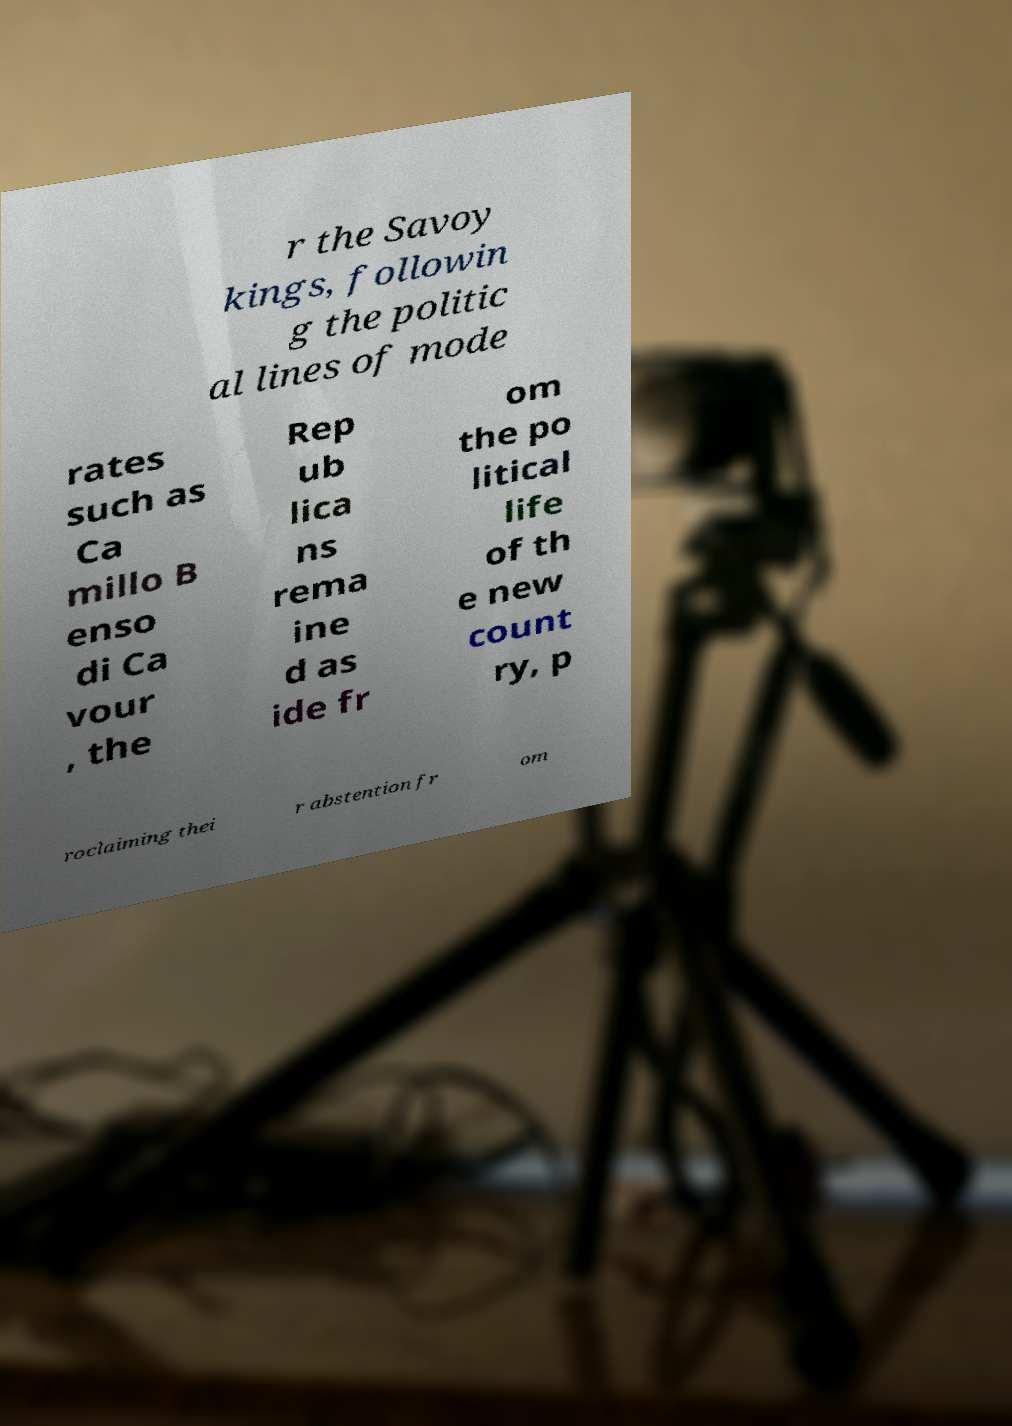Could you extract and type out the text from this image? r the Savoy kings, followin g the politic al lines of mode rates such as Ca millo B enso di Ca vour , the Rep ub lica ns rema ine d as ide fr om the po litical life of th e new count ry, p roclaiming thei r abstention fr om 